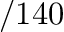Convert formula to latex. <formula><loc_0><loc_0><loc_500><loc_500>/ 1 4 0</formula> 